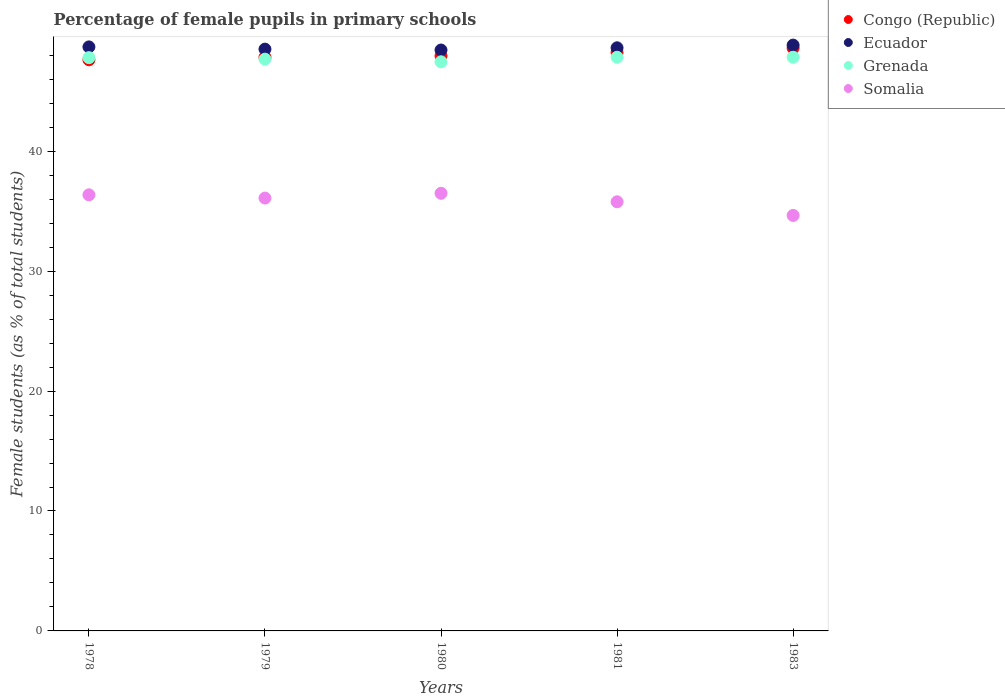What is the percentage of female pupils in primary schools in Ecuador in 1983?
Offer a very short reply. 48.85. Across all years, what is the maximum percentage of female pupils in primary schools in Grenada?
Offer a very short reply. 47.84. Across all years, what is the minimum percentage of female pupils in primary schools in Grenada?
Make the answer very short. 47.46. In which year was the percentage of female pupils in primary schools in Grenada minimum?
Your response must be concise. 1980. What is the total percentage of female pupils in primary schools in Somalia in the graph?
Give a very brief answer. 179.38. What is the difference between the percentage of female pupils in primary schools in Grenada in 1978 and that in 1979?
Your answer should be very brief. 0.13. What is the difference between the percentage of female pupils in primary schools in Somalia in 1983 and the percentage of female pupils in primary schools in Ecuador in 1981?
Offer a very short reply. -13.98. What is the average percentage of female pupils in primary schools in Congo (Republic) per year?
Make the answer very short. 48.05. In the year 1981, what is the difference between the percentage of female pupils in primary schools in Congo (Republic) and percentage of female pupils in primary schools in Ecuador?
Ensure brevity in your answer.  -0.39. What is the ratio of the percentage of female pupils in primary schools in Somalia in 1979 to that in 1980?
Your answer should be compact. 0.99. Is the percentage of female pupils in primary schools in Congo (Republic) in 1978 less than that in 1979?
Provide a short and direct response. Yes. Is the difference between the percentage of female pupils in primary schools in Congo (Republic) in 1980 and 1981 greater than the difference between the percentage of female pupils in primary schools in Ecuador in 1980 and 1981?
Your response must be concise. No. What is the difference between the highest and the second highest percentage of female pupils in primary schools in Ecuador?
Provide a short and direct response. 0.15. What is the difference between the highest and the lowest percentage of female pupils in primary schools in Grenada?
Keep it short and to the point. 0.38. Is the sum of the percentage of female pupils in primary schools in Somalia in 1978 and 1981 greater than the maximum percentage of female pupils in primary schools in Ecuador across all years?
Keep it short and to the point. Yes. Is it the case that in every year, the sum of the percentage of female pupils in primary schools in Ecuador and percentage of female pupils in primary schools in Grenada  is greater than the sum of percentage of female pupils in primary schools in Congo (Republic) and percentage of female pupils in primary schools in Somalia?
Offer a very short reply. No. Is the percentage of female pupils in primary schools in Somalia strictly greater than the percentage of female pupils in primary schools in Ecuador over the years?
Give a very brief answer. No. What is the difference between two consecutive major ticks on the Y-axis?
Your answer should be compact. 10. Are the values on the major ticks of Y-axis written in scientific E-notation?
Make the answer very short. No. Where does the legend appear in the graph?
Keep it short and to the point. Top right. How are the legend labels stacked?
Provide a succinct answer. Vertical. What is the title of the graph?
Offer a terse response. Percentage of female pupils in primary schools. What is the label or title of the Y-axis?
Your answer should be very brief. Female students (as % of total students). What is the Female students (as % of total students) in Congo (Republic) in 1978?
Your answer should be compact. 47.62. What is the Female students (as % of total students) in Ecuador in 1978?
Keep it short and to the point. 48.7. What is the Female students (as % of total students) of Grenada in 1978?
Make the answer very short. 47.8. What is the Female students (as % of total students) of Somalia in 1978?
Your answer should be compact. 36.36. What is the Female students (as % of total students) in Congo (Republic) in 1979?
Your answer should be very brief. 47.83. What is the Female students (as % of total students) in Ecuador in 1979?
Give a very brief answer. 48.51. What is the Female students (as % of total students) in Grenada in 1979?
Make the answer very short. 47.68. What is the Female students (as % of total students) of Somalia in 1979?
Offer a very short reply. 36.09. What is the Female students (as % of total students) in Congo (Republic) in 1980?
Offer a terse response. 47.95. What is the Female students (as % of total students) in Ecuador in 1980?
Give a very brief answer. 48.44. What is the Female students (as % of total students) in Grenada in 1980?
Provide a short and direct response. 47.46. What is the Female students (as % of total students) in Somalia in 1980?
Offer a terse response. 36.49. What is the Female students (as % of total students) in Congo (Republic) in 1981?
Provide a succinct answer. 48.23. What is the Female students (as % of total students) of Ecuador in 1981?
Ensure brevity in your answer.  48.62. What is the Female students (as % of total students) in Grenada in 1981?
Ensure brevity in your answer.  47.84. What is the Female students (as % of total students) of Somalia in 1981?
Make the answer very short. 35.78. What is the Female students (as % of total students) of Congo (Republic) in 1983?
Offer a terse response. 48.6. What is the Female students (as % of total students) in Ecuador in 1983?
Keep it short and to the point. 48.85. What is the Female students (as % of total students) of Grenada in 1983?
Provide a succinct answer. 47.84. What is the Female students (as % of total students) of Somalia in 1983?
Offer a very short reply. 34.65. Across all years, what is the maximum Female students (as % of total students) in Congo (Republic)?
Provide a short and direct response. 48.6. Across all years, what is the maximum Female students (as % of total students) in Ecuador?
Offer a terse response. 48.85. Across all years, what is the maximum Female students (as % of total students) in Grenada?
Keep it short and to the point. 47.84. Across all years, what is the maximum Female students (as % of total students) in Somalia?
Keep it short and to the point. 36.49. Across all years, what is the minimum Female students (as % of total students) of Congo (Republic)?
Your answer should be compact. 47.62. Across all years, what is the minimum Female students (as % of total students) in Ecuador?
Your answer should be compact. 48.44. Across all years, what is the minimum Female students (as % of total students) in Grenada?
Provide a succinct answer. 47.46. Across all years, what is the minimum Female students (as % of total students) of Somalia?
Provide a short and direct response. 34.65. What is the total Female students (as % of total students) in Congo (Republic) in the graph?
Give a very brief answer. 240.23. What is the total Female students (as % of total students) of Ecuador in the graph?
Give a very brief answer. 243.12. What is the total Female students (as % of total students) in Grenada in the graph?
Ensure brevity in your answer.  238.61. What is the total Female students (as % of total students) in Somalia in the graph?
Ensure brevity in your answer.  179.38. What is the difference between the Female students (as % of total students) of Congo (Republic) in 1978 and that in 1979?
Your response must be concise. -0.21. What is the difference between the Female students (as % of total students) of Ecuador in 1978 and that in 1979?
Your answer should be compact. 0.19. What is the difference between the Female students (as % of total students) in Grenada in 1978 and that in 1979?
Provide a succinct answer. 0.13. What is the difference between the Female students (as % of total students) in Somalia in 1978 and that in 1979?
Make the answer very short. 0.27. What is the difference between the Female students (as % of total students) in Congo (Republic) in 1978 and that in 1980?
Your response must be concise. -0.32. What is the difference between the Female students (as % of total students) of Ecuador in 1978 and that in 1980?
Your response must be concise. 0.26. What is the difference between the Female students (as % of total students) in Grenada in 1978 and that in 1980?
Ensure brevity in your answer.  0.35. What is the difference between the Female students (as % of total students) of Somalia in 1978 and that in 1980?
Give a very brief answer. -0.13. What is the difference between the Female students (as % of total students) of Congo (Republic) in 1978 and that in 1981?
Offer a very short reply. -0.61. What is the difference between the Female students (as % of total students) of Ecuador in 1978 and that in 1981?
Your answer should be very brief. 0.07. What is the difference between the Female students (as % of total students) of Grenada in 1978 and that in 1981?
Make the answer very short. -0.03. What is the difference between the Female students (as % of total students) in Somalia in 1978 and that in 1981?
Make the answer very short. 0.58. What is the difference between the Female students (as % of total students) in Congo (Republic) in 1978 and that in 1983?
Give a very brief answer. -0.97. What is the difference between the Female students (as % of total students) in Ecuador in 1978 and that in 1983?
Give a very brief answer. -0.15. What is the difference between the Female students (as % of total students) of Grenada in 1978 and that in 1983?
Provide a succinct answer. -0.03. What is the difference between the Female students (as % of total students) of Somalia in 1978 and that in 1983?
Provide a short and direct response. 1.72. What is the difference between the Female students (as % of total students) in Congo (Republic) in 1979 and that in 1980?
Your response must be concise. -0.12. What is the difference between the Female students (as % of total students) of Ecuador in 1979 and that in 1980?
Provide a succinct answer. 0.07. What is the difference between the Female students (as % of total students) of Grenada in 1979 and that in 1980?
Ensure brevity in your answer.  0.22. What is the difference between the Female students (as % of total students) in Somalia in 1979 and that in 1980?
Your answer should be compact. -0.4. What is the difference between the Female students (as % of total students) of Congo (Republic) in 1979 and that in 1981?
Ensure brevity in your answer.  -0.4. What is the difference between the Female students (as % of total students) of Ecuador in 1979 and that in 1981?
Your answer should be compact. -0.11. What is the difference between the Female students (as % of total students) of Grenada in 1979 and that in 1981?
Your answer should be very brief. -0.16. What is the difference between the Female students (as % of total students) in Somalia in 1979 and that in 1981?
Offer a very short reply. 0.31. What is the difference between the Female students (as % of total students) in Congo (Republic) in 1979 and that in 1983?
Provide a succinct answer. -0.77. What is the difference between the Female students (as % of total students) in Ecuador in 1979 and that in 1983?
Provide a succinct answer. -0.34. What is the difference between the Female students (as % of total students) of Grenada in 1979 and that in 1983?
Provide a succinct answer. -0.16. What is the difference between the Female students (as % of total students) in Somalia in 1979 and that in 1983?
Your answer should be very brief. 1.45. What is the difference between the Female students (as % of total students) in Congo (Republic) in 1980 and that in 1981?
Ensure brevity in your answer.  -0.28. What is the difference between the Female students (as % of total students) in Ecuador in 1980 and that in 1981?
Your answer should be compact. -0.18. What is the difference between the Female students (as % of total students) in Grenada in 1980 and that in 1981?
Keep it short and to the point. -0.38. What is the difference between the Female students (as % of total students) of Somalia in 1980 and that in 1981?
Ensure brevity in your answer.  0.71. What is the difference between the Female students (as % of total students) in Congo (Republic) in 1980 and that in 1983?
Your answer should be very brief. -0.65. What is the difference between the Female students (as % of total students) of Ecuador in 1980 and that in 1983?
Your answer should be very brief. -0.41. What is the difference between the Female students (as % of total students) in Grenada in 1980 and that in 1983?
Provide a succinct answer. -0.38. What is the difference between the Female students (as % of total students) in Somalia in 1980 and that in 1983?
Your answer should be very brief. 1.85. What is the difference between the Female students (as % of total students) in Congo (Republic) in 1981 and that in 1983?
Your answer should be very brief. -0.37. What is the difference between the Female students (as % of total students) of Ecuador in 1981 and that in 1983?
Keep it short and to the point. -0.23. What is the difference between the Female students (as % of total students) of Grenada in 1981 and that in 1983?
Offer a terse response. 0. What is the difference between the Female students (as % of total students) of Somalia in 1981 and that in 1983?
Your answer should be compact. 1.14. What is the difference between the Female students (as % of total students) in Congo (Republic) in 1978 and the Female students (as % of total students) in Ecuador in 1979?
Keep it short and to the point. -0.89. What is the difference between the Female students (as % of total students) of Congo (Republic) in 1978 and the Female students (as % of total students) of Grenada in 1979?
Offer a terse response. -0.05. What is the difference between the Female students (as % of total students) of Congo (Republic) in 1978 and the Female students (as % of total students) of Somalia in 1979?
Offer a terse response. 11.53. What is the difference between the Female students (as % of total students) of Ecuador in 1978 and the Female students (as % of total students) of Grenada in 1979?
Make the answer very short. 1.02. What is the difference between the Female students (as % of total students) in Ecuador in 1978 and the Female students (as % of total students) in Somalia in 1979?
Offer a very short reply. 12.6. What is the difference between the Female students (as % of total students) of Grenada in 1978 and the Female students (as % of total students) of Somalia in 1979?
Your answer should be compact. 11.71. What is the difference between the Female students (as % of total students) of Congo (Republic) in 1978 and the Female students (as % of total students) of Ecuador in 1980?
Your response must be concise. -0.81. What is the difference between the Female students (as % of total students) of Congo (Republic) in 1978 and the Female students (as % of total students) of Grenada in 1980?
Provide a short and direct response. 0.17. What is the difference between the Female students (as % of total students) of Congo (Republic) in 1978 and the Female students (as % of total students) of Somalia in 1980?
Keep it short and to the point. 11.13. What is the difference between the Female students (as % of total students) of Ecuador in 1978 and the Female students (as % of total students) of Grenada in 1980?
Keep it short and to the point. 1.24. What is the difference between the Female students (as % of total students) of Ecuador in 1978 and the Female students (as % of total students) of Somalia in 1980?
Ensure brevity in your answer.  12.21. What is the difference between the Female students (as % of total students) of Grenada in 1978 and the Female students (as % of total students) of Somalia in 1980?
Your response must be concise. 11.31. What is the difference between the Female students (as % of total students) of Congo (Republic) in 1978 and the Female students (as % of total students) of Ecuador in 1981?
Make the answer very short. -1. What is the difference between the Female students (as % of total students) in Congo (Republic) in 1978 and the Female students (as % of total students) in Grenada in 1981?
Provide a short and direct response. -0.21. What is the difference between the Female students (as % of total students) in Congo (Republic) in 1978 and the Female students (as % of total students) in Somalia in 1981?
Ensure brevity in your answer.  11.84. What is the difference between the Female students (as % of total students) in Ecuador in 1978 and the Female students (as % of total students) in Grenada in 1981?
Offer a terse response. 0.86. What is the difference between the Female students (as % of total students) in Ecuador in 1978 and the Female students (as % of total students) in Somalia in 1981?
Make the answer very short. 12.91. What is the difference between the Female students (as % of total students) of Grenada in 1978 and the Female students (as % of total students) of Somalia in 1981?
Keep it short and to the point. 12.02. What is the difference between the Female students (as % of total students) in Congo (Republic) in 1978 and the Female students (as % of total students) in Ecuador in 1983?
Your answer should be compact. -1.23. What is the difference between the Female students (as % of total students) in Congo (Republic) in 1978 and the Female students (as % of total students) in Grenada in 1983?
Keep it short and to the point. -0.21. What is the difference between the Female students (as % of total students) of Congo (Republic) in 1978 and the Female students (as % of total students) of Somalia in 1983?
Your answer should be compact. 12.98. What is the difference between the Female students (as % of total students) in Ecuador in 1978 and the Female students (as % of total students) in Grenada in 1983?
Provide a succinct answer. 0.86. What is the difference between the Female students (as % of total students) of Ecuador in 1978 and the Female students (as % of total students) of Somalia in 1983?
Ensure brevity in your answer.  14.05. What is the difference between the Female students (as % of total students) of Grenada in 1978 and the Female students (as % of total students) of Somalia in 1983?
Offer a terse response. 13.16. What is the difference between the Female students (as % of total students) of Congo (Republic) in 1979 and the Female students (as % of total students) of Ecuador in 1980?
Provide a succinct answer. -0.61. What is the difference between the Female students (as % of total students) of Congo (Republic) in 1979 and the Female students (as % of total students) of Grenada in 1980?
Provide a short and direct response. 0.37. What is the difference between the Female students (as % of total students) of Congo (Republic) in 1979 and the Female students (as % of total students) of Somalia in 1980?
Give a very brief answer. 11.34. What is the difference between the Female students (as % of total students) in Ecuador in 1979 and the Female students (as % of total students) in Grenada in 1980?
Give a very brief answer. 1.06. What is the difference between the Female students (as % of total students) in Ecuador in 1979 and the Female students (as % of total students) in Somalia in 1980?
Offer a terse response. 12.02. What is the difference between the Female students (as % of total students) in Grenada in 1979 and the Female students (as % of total students) in Somalia in 1980?
Offer a very short reply. 11.19. What is the difference between the Female students (as % of total students) in Congo (Republic) in 1979 and the Female students (as % of total students) in Ecuador in 1981?
Make the answer very short. -0.79. What is the difference between the Female students (as % of total students) in Congo (Republic) in 1979 and the Female students (as % of total students) in Grenada in 1981?
Ensure brevity in your answer.  -0.01. What is the difference between the Female students (as % of total students) in Congo (Republic) in 1979 and the Female students (as % of total students) in Somalia in 1981?
Provide a short and direct response. 12.05. What is the difference between the Female students (as % of total students) of Ecuador in 1979 and the Female students (as % of total students) of Grenada in 1981?
Provide a short and direct response. 0.68. What is the difference between the Female students (as % of total students) in Ecuador in 1979 and the Female students (as % of total students) in Somalia in 1981?
Offer a very short reply. 12.73. What is the difference between the Female students (as % of total students) in Grenada in 1979 and the Female students (as % of total students) in Somalia in 1981?
Give a very brief answer. 11.89. What is the difference between the Female students (as % of total students) in Congo (Republic) in 1979 and the Female students (as % of total students) in Ecuador in 1983?
Give a very brief answer. -1.02. What is the difference between the Female students (as % of total students) of Congo (Republic) in 1979 and the Female students (as % of total students) of Grenada in 1983?
Offer a very short reply. -0.01. What is the difference between the Female students (as % of total students) of Congo (Republic) in 1979 and the Female students (as % of total students) of Somalia in 1983?
Provide a short and direct response. 13.19. What is the difference between the Female students (as % of total students) in Ecuador in 1979 and the Female students (as % of total students) in Grenada in 1983?
Offer a very short reply. 0.68. What is the difference between the Female students (as % of total students) in Ecuador in 1979 and the Female students (as % of total students) in Somalia in 1983?
Your answer should be compact. 13.87. What is the difference between the Female students (as % of total students) of Grenada in 1979 and the Female students (as % of total students) of Somalia in 1983?
Give a very brief answer. 13.03. What is the difference between the Female students (as % of total students) in Congo (Republic) in 1980 and the Female students (as % of total students) in Ecuador in 1981?
Provide a short and direct response. -0.68. What is the difference between the Female students (as % of total students) of Congo (Republic) in 1980 and the Female students (as % of total students) of Grenada in 1981?
Give a very brief answer. 0.11. What is the difference between the Female students (as % of total students) of Congo (Republic) in 1980 and the Female students (as % of total students) of Somalia in 1981?
Make the answer very short. 12.16. What is the difference between the Female students (as % of total students) in Ecuador in 1980 and the Female students (as % of total students) in Grenada in 1981?
Provide a short and direct response. 0.6. What is the difference between the Female students (as % of total students) in Ecuador in 1980 and the Female students (as % of total students) in Somalia in 1981?
Your answer should be compact. 12.66. What is the difference between the Female students (as % of total students) of Grenada in 1980 and the Female students (as % of total students) of Somalia in 1981?
Provide a short and direct response. 11.67. What is the difference between the Female students (as % of total students) in Congo (Republic) in 1980 and the Female students (as % of total students) in Ecuador in 1983?
Provide a succinct answer. -0.9. What is the difference between the Female students (as % of total students) in Congo (Republic) in 1980 and the Female students (as % of total students) in Grenada in 1983?
Provide a short and direct response. 0.11. What is the difference between the Female students (as % of total students) of Congo (Republic) in 1980 and the Female students (as % of total students) of Somalia in 1983?
Your answer should be very brief. 13.3. What is the difference between the Female students (as % of total students) in Ecuador in 1980 and the Female students (as % of total students) in Grenada in 1983?
Offer a very short reply. 0.6. What is the difference between the Female students (as % of total students) in Ecuador in 1980 and the Female students (as % of total students) in Somalia in 1983?
Offer a very short reply. 13.79. What is the difference between the Female students (as % of total students) in Grenada in 1980 and the Female students (as % of total students) in Somalia in 1983?
Make the answer very short. 12.81. What is the difference between the Female students (as % of total students) in Congo (Republic) in 1981 and the Female students (as % of total students) in Ecuador in 1983?
Your answer should be very brief. -0.62. What is the difference between the Female students (as % of total students) of Congo (Republic) in 1981 and the Female students (as % of total students) of Grenada in 1983?
Your response must be concise. 0.4. What is the difference between the Female students (as % of total students) of Congo (Republic) in 1981 and the Female students (as % of total students) of Somalia in 1983?
Keep it short and to the point. 13.59. What is the difference between the Female students (as % of total students) in Ecuador in 1981 and the Female students (as % of total students) in Grenada in 1983?
Your response must be concise. 0.79. What is the difference between the Female students (as % of total students) of Ecuador in 1981 and the Female students (as % of total students) of Somalia in 1983?
Offer a terse response. 13.98. What is the difference between the Female students (as % of total students) of Grenada in 1981 and the Female students (as % of total students) of Somalia in 1983?
Provide a short and direct response. 13.19. What is the average Female students (as % of total students) in Congo (Republic) per year?
Your answer should be very brief. 48.05. What is the average Female students (as % of total students) in Ecuador per year?
Your answer should be compact. 48.62. What is the average Female students (as % of total students) of Grenada per year?
Offer a terse response. 47.72. What is the average Female students (as % of total students) in Somalia per year?
Offer a very short reply. 35.88. In the year 1978, what is the difference between the Female students (as % of total students) of Congo (Republic) and Female students (as % of total students) of Ecuador?
Ensure brevity in your answer.  -1.07. In the year 1978, what is the difference between the Female students (as % of total students) in Congo (Republic) and Female students (as % of total students) in Grenada?
Give a very brief answer. -0.18. In the year 1978, what is the difference between the Female students (as % of total students) of Congo (Republic) and Female students (as % of total students) of Somalia?
Give a very brief answer. 11.26. In the year 1978, what is the difference between the Female students (as % of total students) of Ecuador and Female students (as % of total students) of Grenada?
Your answer should be very brief. 0.9. In the year 1978, what is the difference between the Female students (as % of total students) in Ecuador and Female students (as % of total students) in Somalia?
Ensure brevity in your answer.  12.33. In the year 1978, what is the difference between the Female students (as % of total students) in Grenada and Female students (as % of total students) in Somalia?
Provide a short and direct response. 11.44. In the year 1979, what is the difference between the Female students (as % of total students) in Congo (Republic) and Female students (as % of total students) in Ecuador?
Provide a succinct answer. -0.68. In the year 1979, what is the difference between the Female students (as % of total students) of Congo (Republic) and Female students (as % of total students) of Grenada?
Give a very brief answer. 0.15. In the year 1979, what is the difference between the Female students (as % of total students) in Congo (Republic) and Female students (as % of total students) in Somalia?
Provide a short and direct response. 11.74. In the year 1979, what is the difference between the Female students (as % of total students) in Ecuador and Female students (as % of total students) in Grenada?
Make the answer very short. 0.84. In the year 1979, what is the difference between the Female students (as % of total students) of Ecuador and Female students (as % of total students) of Somalia?
Offer a terse response. 12.42. In the year 1979, what is the difference between the Female students (as % of total students) in Grenada and Female students (as % of total students) in Somalia?
Give a very brief answer. 11.58. In the year 1980, what is the difference between the Female students (as % of total students) in Congo (Republic) and Female students (as % of total students) in Ecuador?
Keep it short and to the point. -0.49. In the year 1980, what is the difference between the Female students (as % of total students) of Congo (Republic) and Female students (as % of total students) of Grenada?
Provide a succinct answer. 0.49. In the year 1980, what is the difference between the Female students (as % of total students) of Congo (Republic) and Female students (as % of total students) of Somalia?
Provide a short and direct response. 11.46. In the year 1980, what is the difference between the Female students (as % of total students) of Ecuador and Female students (as % of total students) of Grenada?
Offer a very short reply. 0.98. In the year 1980, what is the difference between the Female students (as % of total students) in Ecuador and Female students (as % of total students) in Somalia?
Keep it short and to the point. 11.95. In the year 1980, what is the difference between the Female students (as % of total students) of Grenada and Female students (as % of total students) of Somalia?
Provide a short and direct response. 10.97. In the year 1981, what is the difference between the Female students (as % of total students) of Congo (Republic) and Female students (as % of total students) of Ecuador?
Offer a very short reply. -0.39. In the year 1981, what is the difference between the Female students (as % of total students) of Congo (Republic) and Female students (as % of total students) of Grenada?
Give a very brief answer. 0.4. In the year 1981, what is the difference between the Female students (as % of total students) of Congo (Republic) and Female students (as % of total students) of Somalia?
Give a very brief answer. 12.45. In the year 1981, what is the difference between the Female students (as % of total students) in Ecuador and Female students (as % of total students) in Grenada?
Offer a terse response. 0.79. In the year 1981, what is the difference between the Female students (as % of total students) of Ecuador and Female students (as % of total students) of Somalia?
Offer a very short reply. 12.84. In the year 1981, what is the difference between the Female students (as % of total students) in Grenada and Female students (as % of total students) in Somalia?
Your response must be concise. 12.05. In the year 1983, what is the difference between the Female students (as % of total students) in Congo (Republic) and Female students (as % of total students) in Ecuador?
Keep it short and to the point. -0.25. In the year 1983, what is the difference between the Female students (as % of total students) in Congo (Republic) and Female students (as % of total students) in Grenada?
Make the answer very short. 0.76. In the year 1983, what is the difference between the Female students (as % of total students) of Congo (Republic) and Female students (as % of total students) of Somalia?
Ensure brevity in your answer.  13.95. In the year 1983, what is the difference between the Female students (as % of total students) in Ecuador and Female students (as % of total students) in Grenada?
Provide a short and direct response. 1.01. In the year 1983, what is the difference between the Female students (as % of total students) in Ecuador and Female students (as % of total students) in Somalia?
Give a very brief answer. 14.2. In the year 1983, what is the difference between the Female students (as % of total students) of Grenada and Female students (as % of total students) of Somalia?
Your answer should be compact. 13.19. What is the ratio of the Female students (as % of total students) in Congo (Republic) in 1978 to that in 1979?
Ensure brevity in your answer.  1. What is the ratio of the Female students (as % of total students) of Ecuador in 1978 to that in 1979?
Offer a terse response. 1. What is the ratio of the Female students (as % of total students) of Grenada in 1978 to that in 1979?
Your answer should be compact. 1. What is the ratio of the Female students (as % of total students) of Somalia in 1978 to that in 1979?
Keep it short and to the point. 1.01. What is the ratio of the Female students (as % of total students) of Congo (Republic) in 1978 to that in 1980?
Ensure brevity in your answer.  0.99. What is the ratio of the Female students (as % of total students) of Ecuador in 1978 to that in 1980?
Provide a short and direct response. 1.01. What is the ratio of the Female students (as % of total students) in Grenada in 1978 to that in 1980?
Your response must be concise. 1.01. What is the ratio of the Female students (as % of total students) in Somalia in 1978 to that in 1980?
Your answer should be very brief. 1. What is the ratio of the Female students (as % of total students) in Congo (Republic) in 1978 to that in 1981?
Offer a very short reply. 0.99. What is the ratio of the Female students (as % of total students) of Somalia in 1978 to that in 1981?
Give a very brief answer. 1.02. What is the ratio of the Female students (as % of total students) in Congo (Republic) in 1978 to that in 1983?
Your response must be concise. 0.98. What is the ratio of the Female students (as % of total students) of Ecuador in 1978 to that in 1983?
Ensure brevity in your answer.  1. What is the ratio of the Female students (as % of total students) in Grenada in 1978 to that in 1983?
Provide a succinct answer. 1. What is the ratio of the Female students (as % of total students) of Somalia in 1978 to that in 1983?
Provide a succinct answer. 1.05. What is the ratio of the Female students (as % of total students) of Congo (Republic) in 1979 to that in 1980?
Offer a very short reply. 1. What is the ratio of the Female students (as % of total students) of Grenada in 1979 to that in 1980?
Make the answer very short. 1. What is the ratio of the Female students (as % of total students) of Grenada in 1979 to that in 1981?
Give a very brief answer. 1. What is the ratio of the Female students (as % of total students) of Somalia in 1979 to that in 1981?
Your answer should be very brief. 1.01. What is the ratio of the Female students (as % of total students) of Congo (Republic) in 1979 to that in 1983?
Provide a short and direct response. 0.98. What is the ratio of the Female students (as % of total students) in Ecuador in 1979 to that in 1983?
Provide a succinct answer. 0.99. What is the ratio of the Female students (as % of total students) in Somalia in 1979 to that in 1983?
Provide a short and direct response. 1.04. What is the ratio of the Female students (as % of total students) in Congo (Republic) in 1980 to that in 1981?
Your response must be concise. 0.99. What is the ratio of the Female students (as % of total students) in Grenada in 1980 to that in 1981?
Offer a terse response. 0.99. What is the ratio of the Female students (as % of total students) in Somalia in 1980 to that in 1981?
Provide a short and direct response. 1.02. What is the ratio of the Female students (as % of total students) in Congo (Republic) in 1980 to that in 1983?
Give a very brief answer. 0.99. What is the ratio of the Female students (as % of total students) of Somalia in 1980 to that in 1983?
Make the answer very short. 1.05. What is the ratio of the Female students (as % of total students) in Grenada in 1981 to that in 1983?
Keep it short and to the point. 1. What is the ratio of the Female students (as % of total students) in Somalia in 1981 to that in 1983?
Your response must be concise. 1.03. What is the difference between the highest and the second highest Female students (as % of total students) of Congo (Republic)?
Your answer should be very brief. 0.37. What is the difference between the highest and the second highest Female students (as % of total students) of Ecuador?
Provide a succinct answer. 0.15. What is the difference between the highest and the second highest Female students (as % of total students) of Grenada?
Keep it short and to the point. 0. What is the difference between the highest and the second highest Female students (as % of total students) in Somalia?
Offer a very short reply. 0.13. What is the difference between the highest and the lowest Female students (as % of total students) of Congo (Republic)?
Your response must be concise. 0.97. What is the difference between the highest and the lowest Female students (as % of total students) of Ecuador?
Offer a terse response. 0.41. What is the difference between the highest and the lowest Female students (as % of total students) of Grenada?
Your answer should be very brief. 0.38. What is the difference between the highest and the lowest Female students (as % of total students) of Somalia?
Your response must be concise. 1.85. 